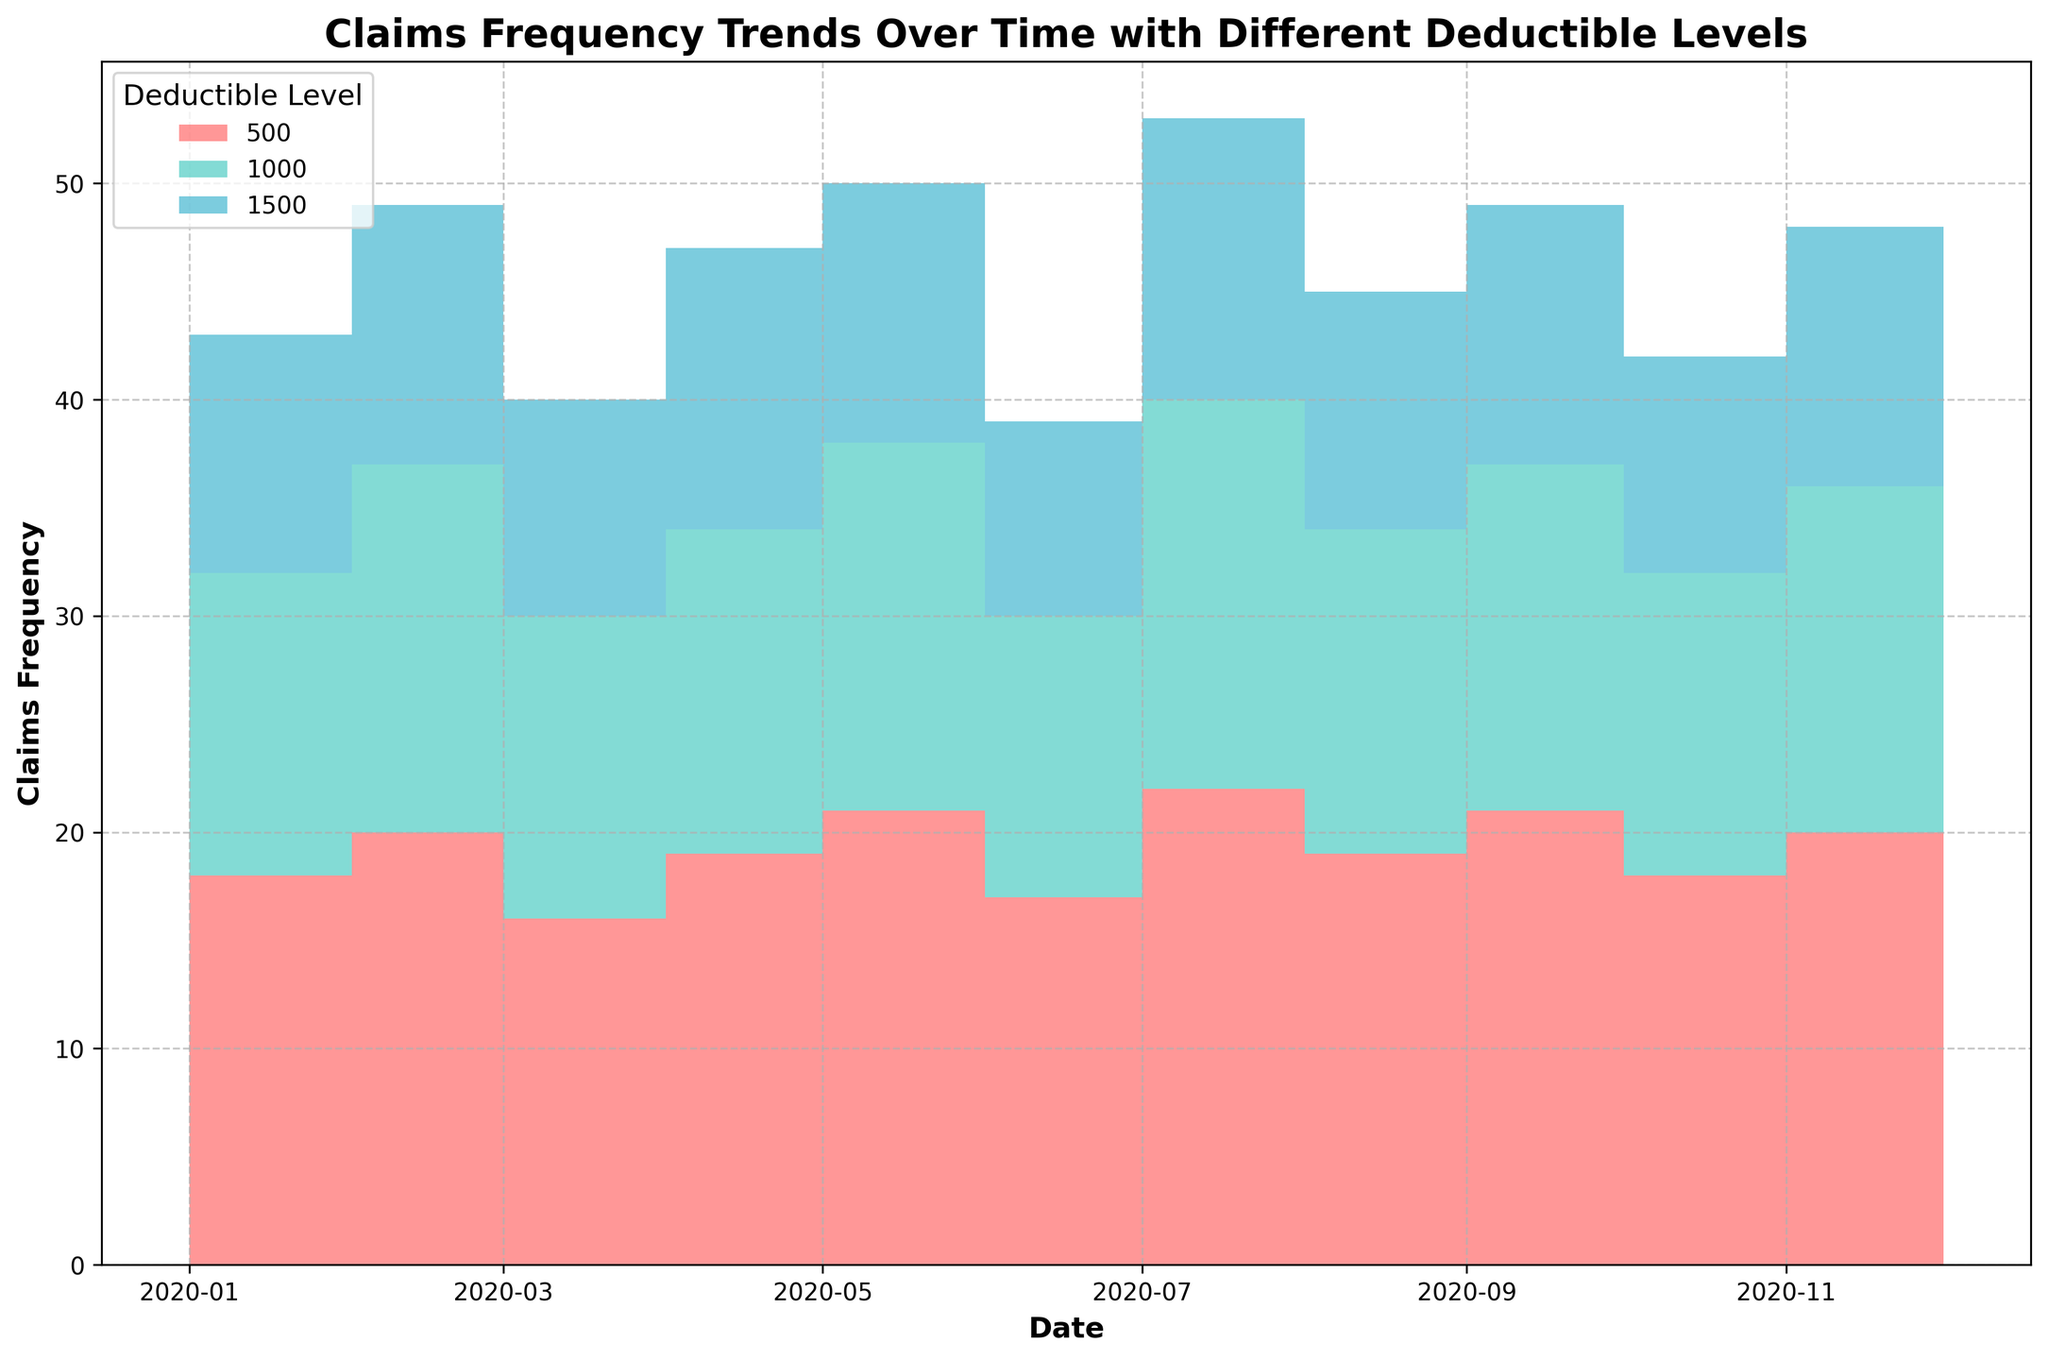What is the title of the figure? The title of the figure can generally be found at the top of the plot and it usually summarizes the content or the main insight of the graphic. The title for this plot is "Claims Frequency Trends Over Time with Different Deductible Levels".
Answer: "Claims Frequency Trends Over Time with Different Deductible Levels" What does the y-axis represent? The y-axis typically represents the quantity being measured. The label on the y-axis in this plot indicates it represents "Claims Frequency".
Answer: Claims Frequency Which deductible level had the highest claims frequency in August 2020? To determine this, look for the point corresponding to August 2020 on the x-axis and check which color appears at the top of the stack for that month. According to the step area chart, the $500 deductible level (red) was on top in August 2020, indicating it had the highest claims frequency.
Answer: $500 How did the claims frequency of the $1000 deductible level change from January 2020 to December 2020? Starting from the value at January 2020 on the x-axis, follow the step line associated with the $1000 deductible (typically a different color) till December 2020. In January, the claims frequency was 12, and in December, it was 16, indicating an increase.
Answer: Increased by 4 What is the combined claims frequency for all deductible levels in March 2020? To get the combined claims frequency, sum up the individual frequencies for each deductible level (500, 1000, 1500) for March 2020. The values are 20, 17, and 12 respectively. Summing these values: 20 + 17 + 12 = 49.
Answer: 49 Which month had the lowest total claims frequency for the $1500 deductible level? Look at the step area corresponding to the $1500 deductible level for each month. The area of the level is lowest in July 2020, indicating that the claims frequency for $1500 deductible was lowest this month, at 9.
Answer: July 2020 Compare the claims frequency trends between the $500 and $1500 deductible levels over the year. What can you deduce? Observing the figure, the claims frequency of the $500 deductible is consistently higher than the $1500 deductible in every month throughout the year. The $500 deductible line generally stays at or near the top of the stack, indicating more claims. Both levels exhibit some periods of increase and decrease, but the $1500 deductible remains lower overall.
Answer: $500 is consistently higher Was there any month where all deductible levels had the same claims frequency? Inspect each month’s stack to find if the heights of every deductible level segment match across a single month. There is no such month where all deductible levels have the same claims frequency, as indicated by the varying height of different colors.
Answer: No What is the average monthly claims frequency for the $1000 deductible level over the year? To find the average, sum up the monthly claims frequencies for the $1000 deductible level and then divide by the number of months (12). The sum is 12 + 14 + 17 + 14 + 15 + 17 + 13 + 18 + 15 + 16 + 14 + 16 = 181. The average is 181 / 12 = 15.08.
Answer: 15.08 If a company wants lower claims frequency, which deductible level appears to be more effective based on this data? By observing the overall trends, it is evident that the $1500 deductible level consistently has the lowest claims frequency every month compared to the $500 and $1000 levels.
Answer: $1500 